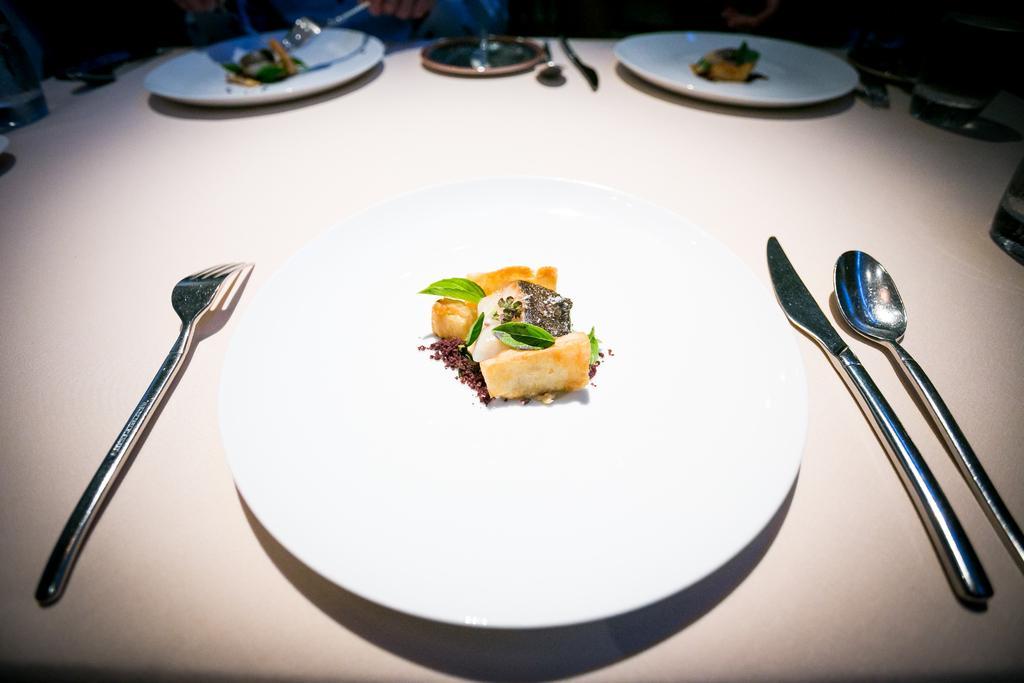Please provide a concise description of this image. In the image there are plate with dessert,mint leaves on it with forks,spoons and knife on either of it on a table. 